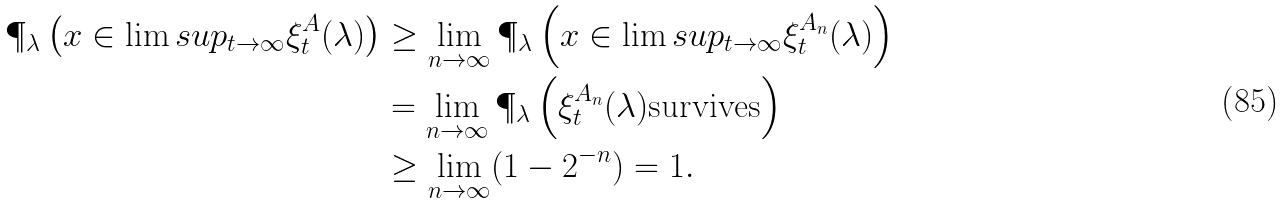<formula> <loc_0><loc_0><loc_500><loc_500>\P _ { \lambda } \left ( x \in \lim s u p _ { t \rightarrow \infty } \xi ^ { A } _ { t } ( \lambda ) \right ) & \geq \lim _ { n \rightarrow \infty } \P _ { \lambda } \left ( x \in \lim s u p _ { t \rightarrow \infty } \xi ^ { A _ { n } } _ { t } ( \lambda ) \right ) \\ & = \lim _ { n \rightarrow \infty } \P _ { \lambda } \left ( \xi ^ { A _ { n } } _ { t } ( \lambda ) \text {survives} \right ) \\ & \geq \lim _ { n \rightarrow \infty } ( 1 - 2 ^ { - n } ) = 1 .</formula> 